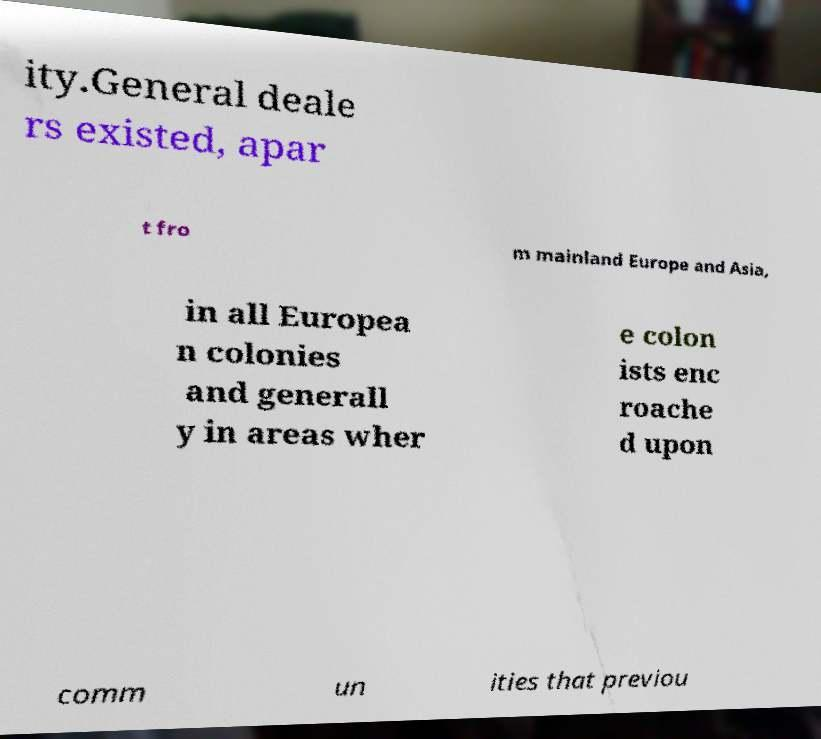Could you extract and type out the text from this image? ity.General deale rs existed, apar t fro m mainland Europe and Asia, in all Europea n colonies and generall y in areas wher e colon ists enc roache d upon comm un ities that previou 